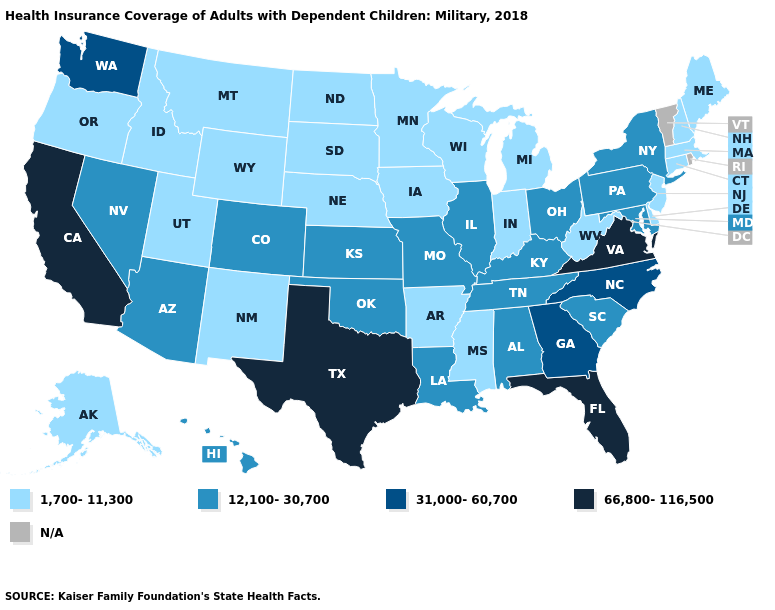Among the states that border Maryland , which have the highest value?
Short answer required. Virginia. What is the value of New Mexico?
Keep it brief. 1,700-11,300. What is the value of North Dakota?
Write a very short answer. 1,700-11,300. Among the states that border Florida , does Alabama have the lowest value?
Keep it brief. Yes. What is the value of North Dakota?
Concise answer only. 1,700-11,300. Among the states that border North Carolina , which have the highest value?
Give a very brief answer. Virginia. Which states have the lowest value in the South?
Be succinct. Arkansas, Delaware, Mississippi, West Virginia. Does Washington have the lowest value in the USA?
Short answer required. No. Does the first symbol in the legend represent the smallest category?
Be succinct. Yes. What is the value of Arkansas?
Answer briefly. 1,700-11,300. What is the highest value in the USA?
Answer briefly. 66,800-116,500. Name the states that have a value in the range 12,100-30,700?
Short answer required. Alabama, Arizona, Colorado, Hawaii, Illinois, Kansas, Kentucky, Louisiana, Maryland, Missouri, Nevada, New York, Ohio, Oklahoma, Pennsylvania, South Carolina, Tennessee. What is the highest value in the USA?
Be succinct. 66,800-116,500. 